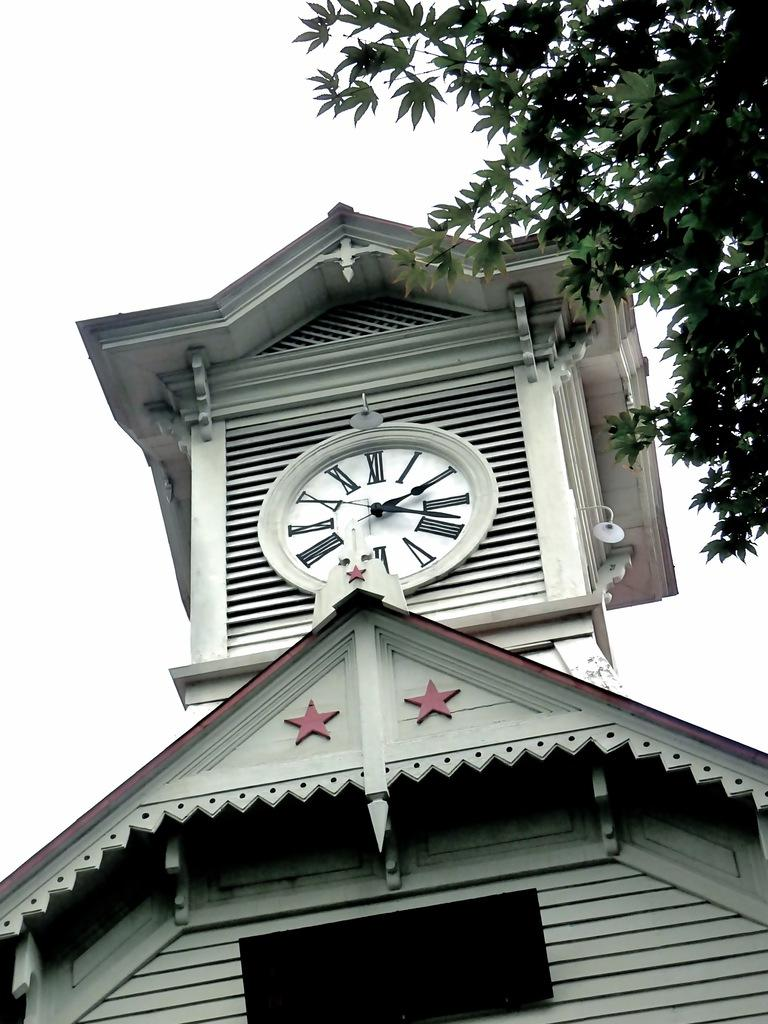<image>
Present a compact description of the photo's key features. A clock tower with the time showing two eighteen. 